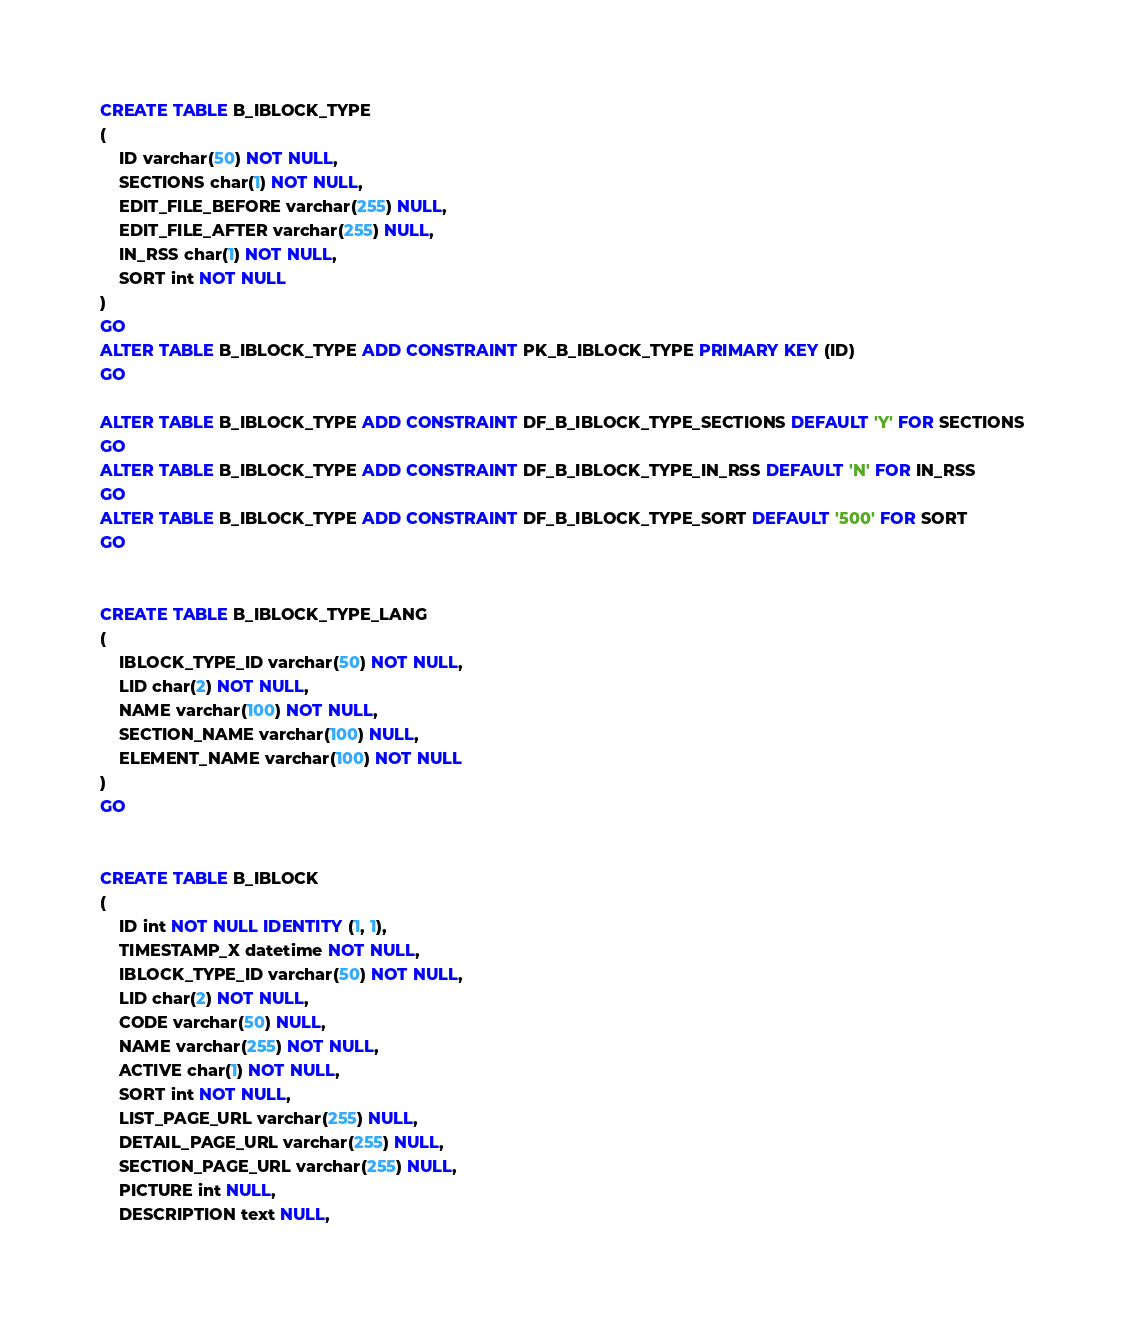<code> <loc_0><loc_0><loc_500><loc_500><_SQL_>CREATE TABLE B_IBLOCK_TYPE
(
	ID varchar(50) NOT NULL,
	SECTIONS char(1) NOT NULL,
	EDIT_FILE_BEFORE varchar(255) NULL,
	EDIT_FILE_AFTER varchar(255) NULL,
	IN_RSS char(1) NOT NULL,
	SORT int NOT NULL
)
GO
ALTER TABLE B_IBLOCK_TYPE ADD CONSTRAINT PK_B_IBLOCK_TYPE PRIMARY KEY (ID)
GO

ALTER TABLE B_IBLOCK_TYPE ADD CONSTRAINT DF_B_IBLOCK_TYPE_SECTIONS DEFAULT 'Y' FOR SECTIONS
GO
ALTER TABLE B_IBLOCK_TYPE ADD CONSTRAINT DF_B_IBLOCK_TYPE_IN_RSS DEFAULT 'N' FOR IN_RSS
GO
ALTER TABLE B_IBLOCK_TYPE ADD CONSTRAINT DF_B_IBLOCK_TYPE_SORT DEFAULT '500' FOR SORT
GO


CREATE TABLE B_IBLOCK_TYPE_LANG
(
	IBLOCK_TYPE_ID varchar(50) NOT NULL,
	LID char(2) NOT NULL,
	NAME varchar(100) NOT NULL,
	SECTION_NAME varchar(100) NULL,
	ELEMENT_NAME varchar(100) NOT NULL
)
GO


CREATE TABLE B_IBLOCK
(
	ID int NOT NULL IDENTITY (1, 1),
	TIMESTAMP_X datetime NOT NULL,
	IBLOCK_TYPE_ID varchar(50) NOT NULL,
	LID char(2) NOT NULL,
	CODE varchar(50) NULL,
	NAME varchar(255) NOT NULL,
	ACTIVE char(1) NOT NULL,
	SORT int NOT NULL,
	LIST_PAGE_URL varchar(255) NULL,
	DETAIL_PAGE_URL varchar(255) NULL,
	SECTION_PAGE_URL varchar(255) NULL,
	PICTURE int NULL,
	DESCRIPTION text NULL,</code> 